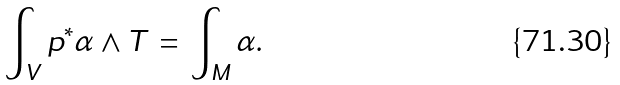Convert formula to latex. <formula><loc_0><loc_0><loc_500><loc_500>\int _ { V } p ^ { * } \alpha \wedge T \, = \, \int _ { M } \alpha .</formula> 